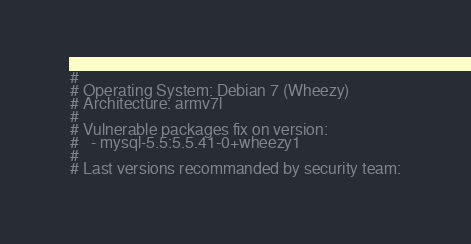<code> <loc_0><loc_0><loc_500><loc_500><_Bash_>#
# Operating System: Debian 7 (Wheezy)
# Architecture: armv7l
#
# Vulnerable packages fix on version:
#   - mysql-5.5:5.5.41-0+wheezy1
#
# Last versions recommanded by security team:</code> 